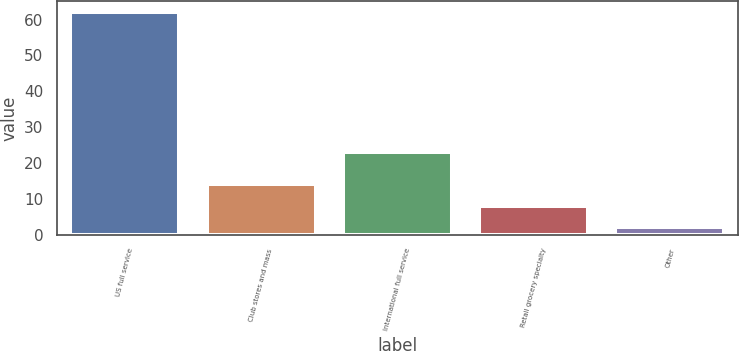<chart> <loc_0><loc_0><loc_500><loc_500><bar_chart><fcel>US full service<fcel>Club stores and mass<fcel>International full service<fcel>Retail grocery specialty<fcel>Other<nl><fcel>62<fcel>14<fcel>23<fcel>8<fcel>2<nl></chart> 